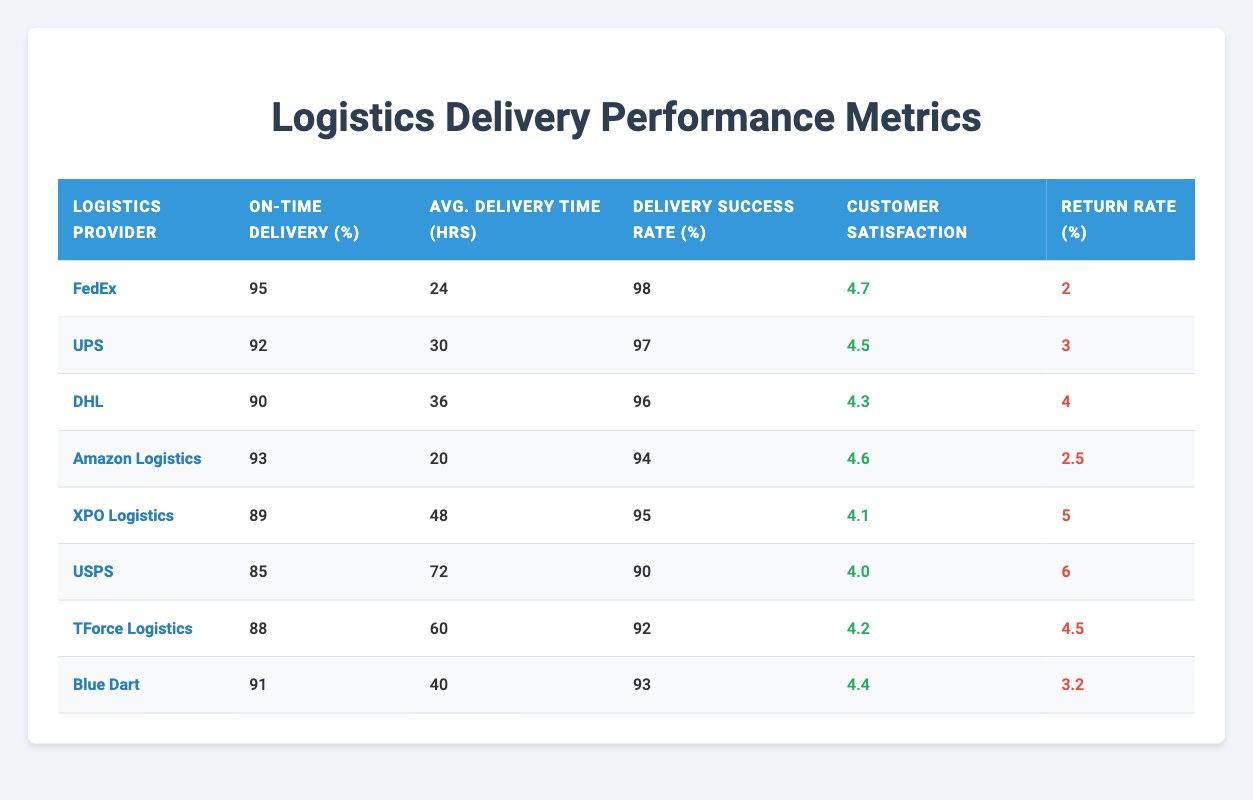What is the On-Time Delivery Percentage for FedEx? FedEx's On-Time Delivery Percentage is listed directly in the table. We can find it in the row corresponding to FedEx under the "On-Time Delivery (%)" column.
Answer: 95 Which logistics provider has the highest Customer Satisfaction Score? To determine the highest Customer Satisfaction Score, we can check the "Customer Satisfaction" column for all providers. By reviewing the scores, we see that FedEx has the highest score at 4.7.
Answer: FedEx What is the average Return Rate of all logistics providers? To find the average Return Rate, we add all the return rates together: (2 + 3 + 4 + 2.5 + 5 + 6 + 4.5 + 3.2) = 30.2. There are 8 logistics providers, so we divide 30.2 by 8. The average Return Rate is 30.2 / 8 = 3.775.
Answer: 3.775 Is the Delivery Success Rate for Amazon Logistics greater than 90? Amazon Logistics has a Delivery Success Rate of 94, which is shown in the "Delivery Success Rate (%)" column. Since 94 is greater than 90, the statement is true.
Answer: Yes Which provider has the lowest Average Delivery Time? We need to look through the "Avg. Delivery Time (hrs)" column. When comparing the values, we find that Amazon Logistics has the lowest value at 20 hours.
Answer: Amazon Logistics What is the difference in On-Time Delivery Percentage between FedEx and UPS? FedEx has an On-Time Delivery Percentage of 95, while UPS has a percentage of 92. To find the difference, we subtract UPS's percentage from FedEx's: 95 - 92 = 3. Thus, the difference is 3 percentage points.
Answer: 3 Which logistics providers have a Return Rate of more than 4%? We need to filter through the "Return Rate (%)" column for values greater than 4%. From the table, we see that XPO Logistics (5), USPS (6), and TForce Logistics (4.5) have return rates above 4%.
Answer: XPO Logistics, USPS, TForce Logistics Is the On-Time Delivery Percentage for DHL lower than that of Blue Dart? Checking the "On-Time Delivery (%)" for both providers shows that DHL has 90% and Blue Dart has 91%. Since 90 is lower than 91, the statement is true.
Answer: Yes What is the maximum Delivery Success Rate among the providers? We can examine the "Delivery Success Rate (%)" column to find the maximum value. By looking through the scores, we see that FedEx has the maximum value at 98.
Answer: 98 